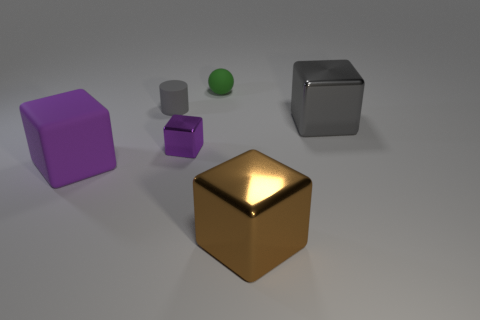Does the big matte object have the same color as the metallic thing that is on the left side of the small green rubber thing?
Provide a short and direct response. Yes. The matte object that is the same color as the tiny shiny cube is what shape?
Offer a terse response. Cube. Is the big matte cube the same color as the small shiny cube?
Your answer should be compact. Yes. There is a object that is the same color as the rubber cube; what is its size?
Provide a short and direct response. Small. What is the size of the gray metallic thing that is the same shape as the brown shiny thing?
Your response must be concise. Large. Do the shiny cube that is on the right side of the brown metal cube and the shiny object that is on the left side of the green rubber thing have the same size?
Provide a short and direct response. No. The cube that is on the right side of the big shiny block that is in front of the thing that is to the left of the tiny rubber cylinder is what color?
Give a very brief answer. Gray. Is there a small purple shiny thing of the same shape as the gray rubber thing?
Your answer should be compact. No. Are there the same number of tiny metal blocks to the left of the small purple object and gray objects to the right of the tiny rubber cylinder?
Give a very brief answer. No. There is a gray object left of the tiny green rubber sphere; is its shape the same as the big brown shiny object?
Offer a terse response. No. 